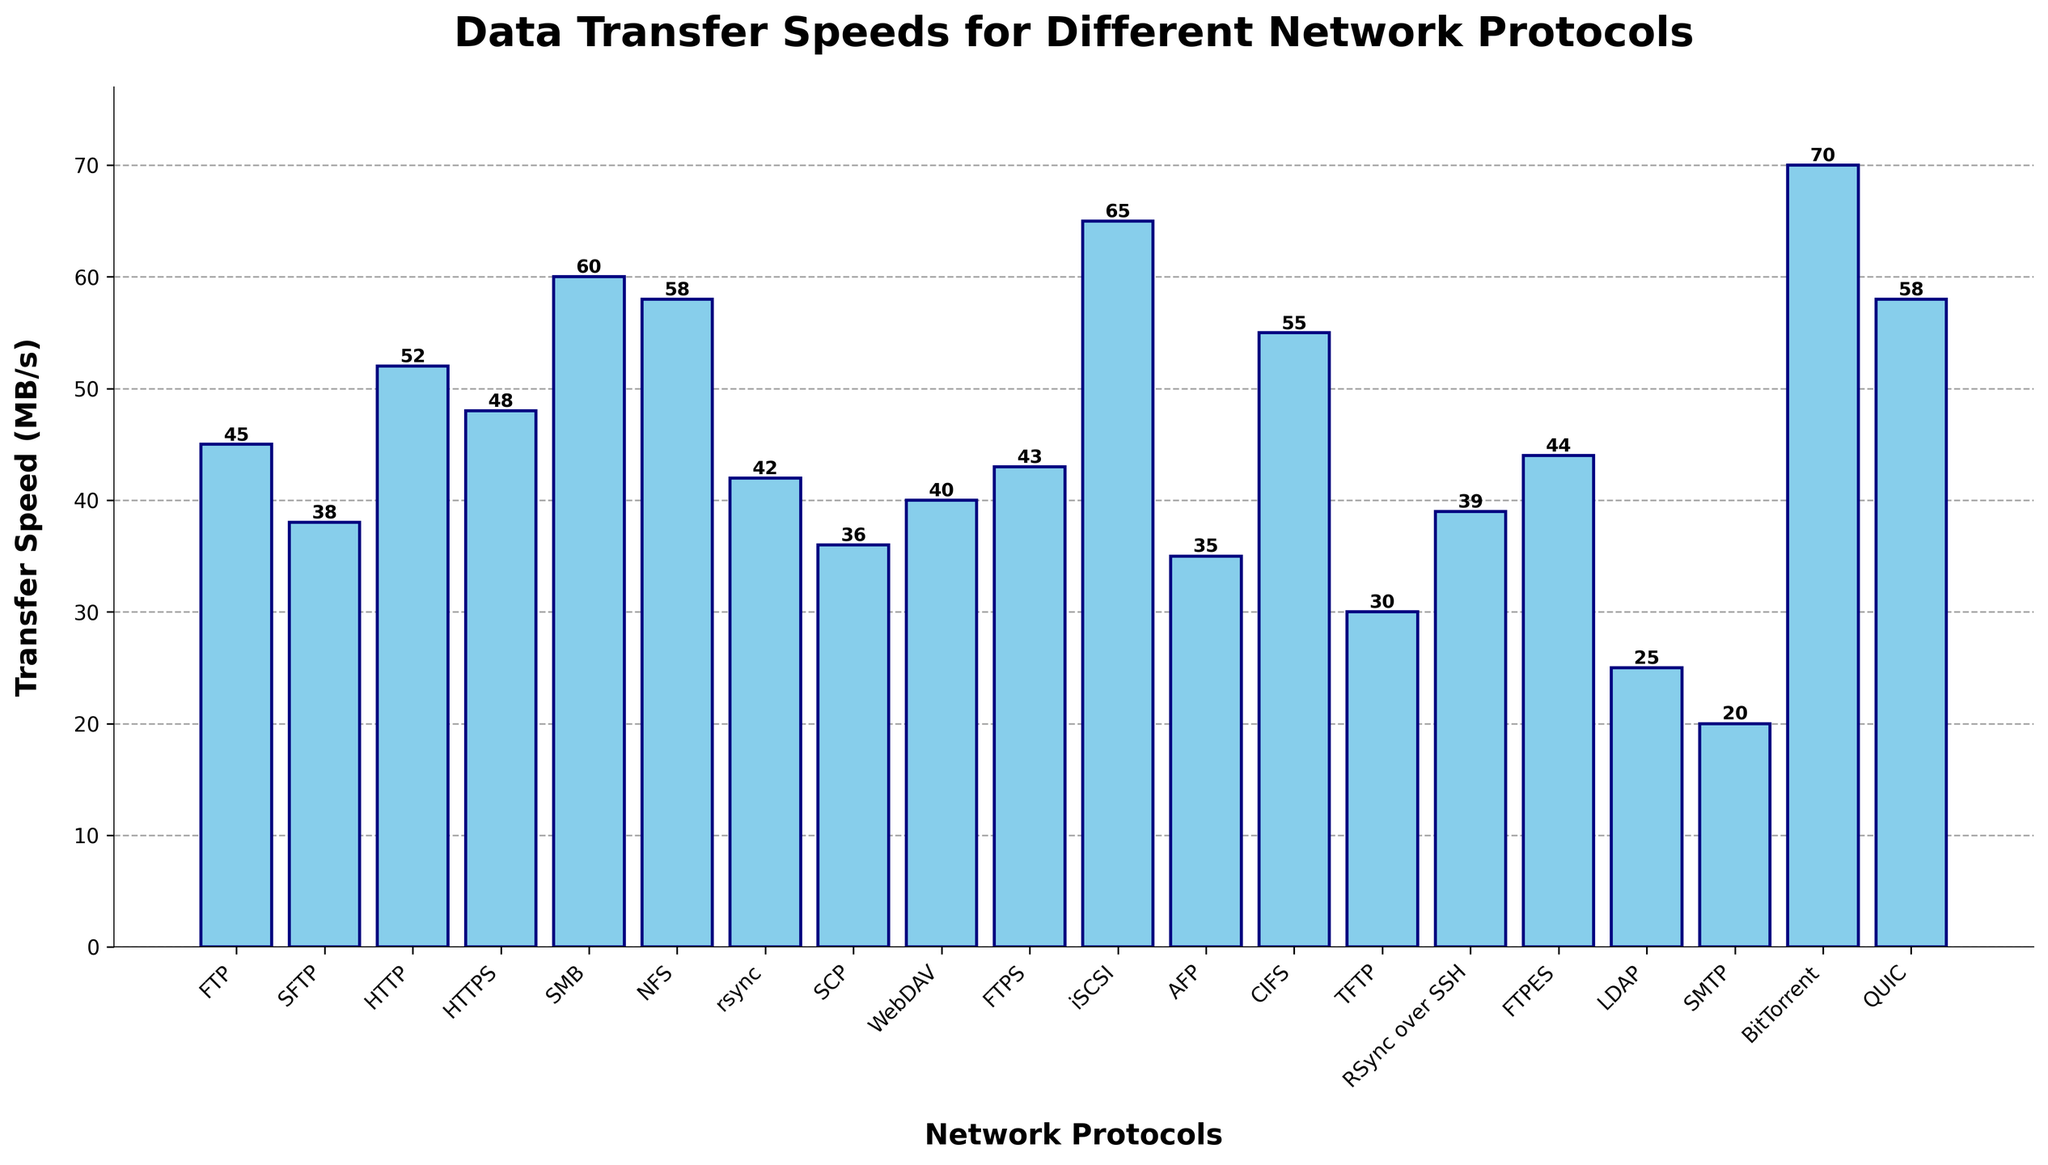What is the fastest data transfer protocol according to the figure? To find the fastest data transfer protocol, look for the bar with the highest value on the vertical axis (Transfer Speed). The highest bar corresponds to 'BitTorrent' at 70 MB/s.
Answer: BitTorrent What is the difference in transfer speed between HTTP and HTTPS? Locate the bars for HTTP and HTTPS. HTTP has a transfer speed of 52 MB/s, and HTTPS has a transfer speed of 48 MB/s. Subtract the smaller value from the larger one: 52 - 48 = 4.
Answer: 4 MB/s Which protocols have a transfer speed greater than 50 MB/s? Identify the bars that are above the 50 MB/s mark. These protocols are HTTP (52 MB/s), HTTPS (48 MB/s), SMB (60 MB/s), NFS (58 MB/s), iSCSI (65 MB/s), BitTorrent (70 MB/s), and QUIC (58 MB/s).
Answer: HTTP, SMB, NFS, iSCSI, BitTorrent, QUIC How does FTP compare to SFTP in terms of transfer speed? Locate the bars for FTP and SFTP. FTP has a transfer speed of 45 MB/s, and SFTP has a transfer speed of 38 MB/s. FTP is faster than SFTP by comparing the heights of the bars and the values.
Answer: FTP is faster What is the average transfer speed of the protocols with speeds less than 40 MB/s? Identify the protocols with speeds less than 40 MB/s: SCP (36 MB/s), WebDAV (40 MB/s), AFP (35 MB/s), TFTP (30 MB/s), LDAP (25 MB/s), and SMTP (20 MB/s). Calculate the average by summing these values and dividing by the number of protocols: (36 + 40 + 35 + 30 + 25 + 20) / 6 = 186 / 6 = 31.
Answer: 31 MB/s Which protocol has the smallest transfer speed and what is it? Look for the smallest bar on the vertical axis. LDAP has the smallest transfer speed, indicated by the height of the bar at 25 MB/s.
Answer: LDAP, 25 MB/s How many protocols have transfer speeds between 40 MB/s and 50 MB/s (inclusive)? Count the bars that fall within the range of 40 MB/s to 50 MB/s. These protocols are FTP (45 MB/s), SFTP (38 MB/s), HTTPS (48 MB/s), rsync (42 MB/s), SCP (36 MB/s), WebDAV (40 MB/s), FTPS (43 MB/s), and RSync over SSH (39 MB/s).
Answer: 5 protocols What is the combined transfer speed of the protocols starting with 'F'? Identify the protocols starting with 'F': FTP (45 MB/s), FTPS (43 MB/s), and FTPES (44 MB/s). Sum these values: 45 + 43 + 44 = 132.
Answer: 132 MB/s 